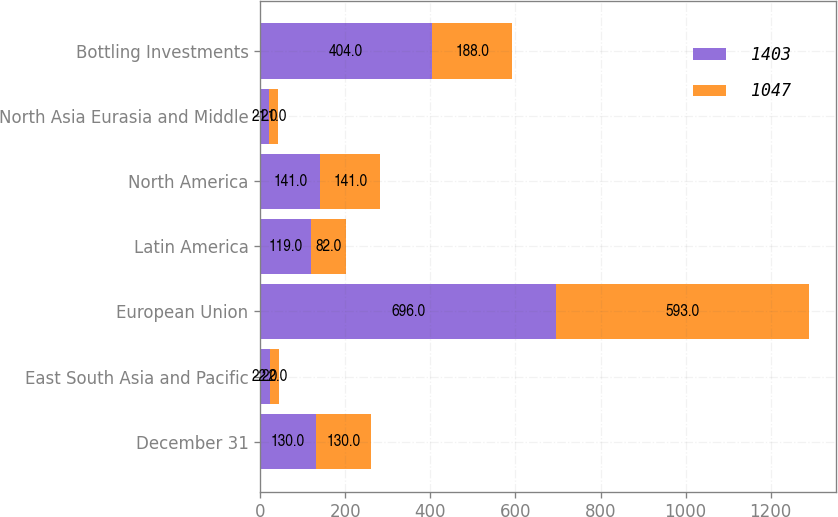Convert chart to OTSL. <chart><loc_0><loc_0><loc_500><loc_500><stacked_bar_chart><ecel><fcel>December 31<fcel>East South Asia and Pacific<fcel>European Union<fcel>Latin America<fcel>North America<fcel>North Asia Eurasia and Middle<fcel>Bottling Investments<nl><fcel>1403<fcel>130<fcel>22<fcel>696<fcel>119<fcel>141<fcel>21<fcel>404<nl><fcel>1047<fcel>130<fcel>22<fcel>593<fcel>82<fcel>141<fcel>21<fcel>188<nl></chart> 